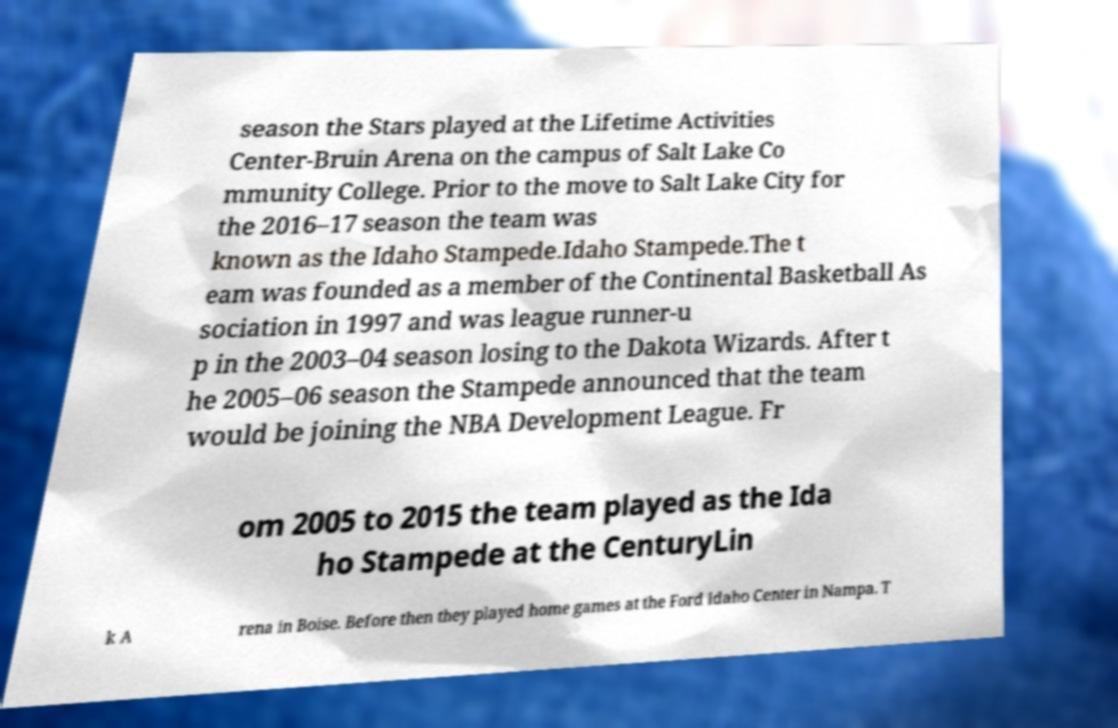Can you read and provide the text displayed in the image?This photo seems to have some interesting text. Can you extract and type it out for me? season the Stars played at the Lifetime Activities Center-Bruin Arena on the campus of Salt Lake Co mmunity College. Prior to the move to Salt Lake City for the 2016–17 season the team was known as the Idaho Stampede.Idaho Stampede.The t eam was founded as a member of the Continental Basketball As sociation in 1997 and was league runner-u p in the 2003–04 season losing to the Dakota Wizards. After t he 2005–06 season the Stampede announced that the team would be joining the NBA Development League. Fr om 2005 to 2015 the team played as the Ida ho Stampede at the CenturyLin k A rena in Boise. Before then they played home games at the Ford Idaho Center in Nampa. T 